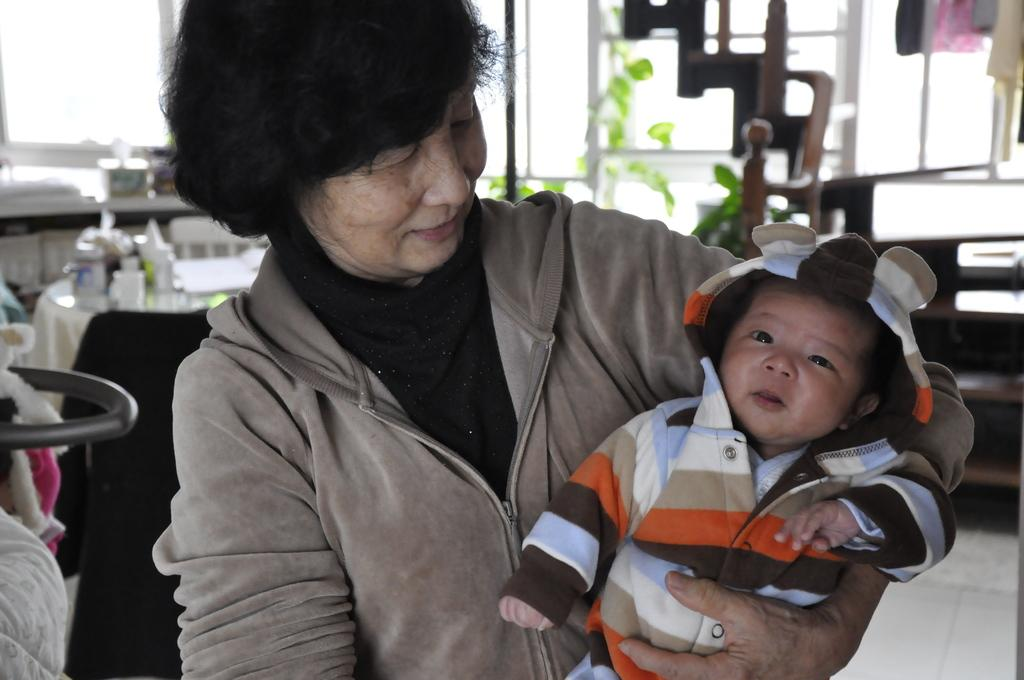Who is the main subject in the image? There is a lady in the center of the image. What is the lady doing in the image? The lady is holding a baby in her hands. What can be seen in the background of the image? There is a table and windows in the background of the image. What type of knee injury is the lady suffering from in the image? There is no indication of a knee injury in the image; the lady is holding a baby in her hands. 